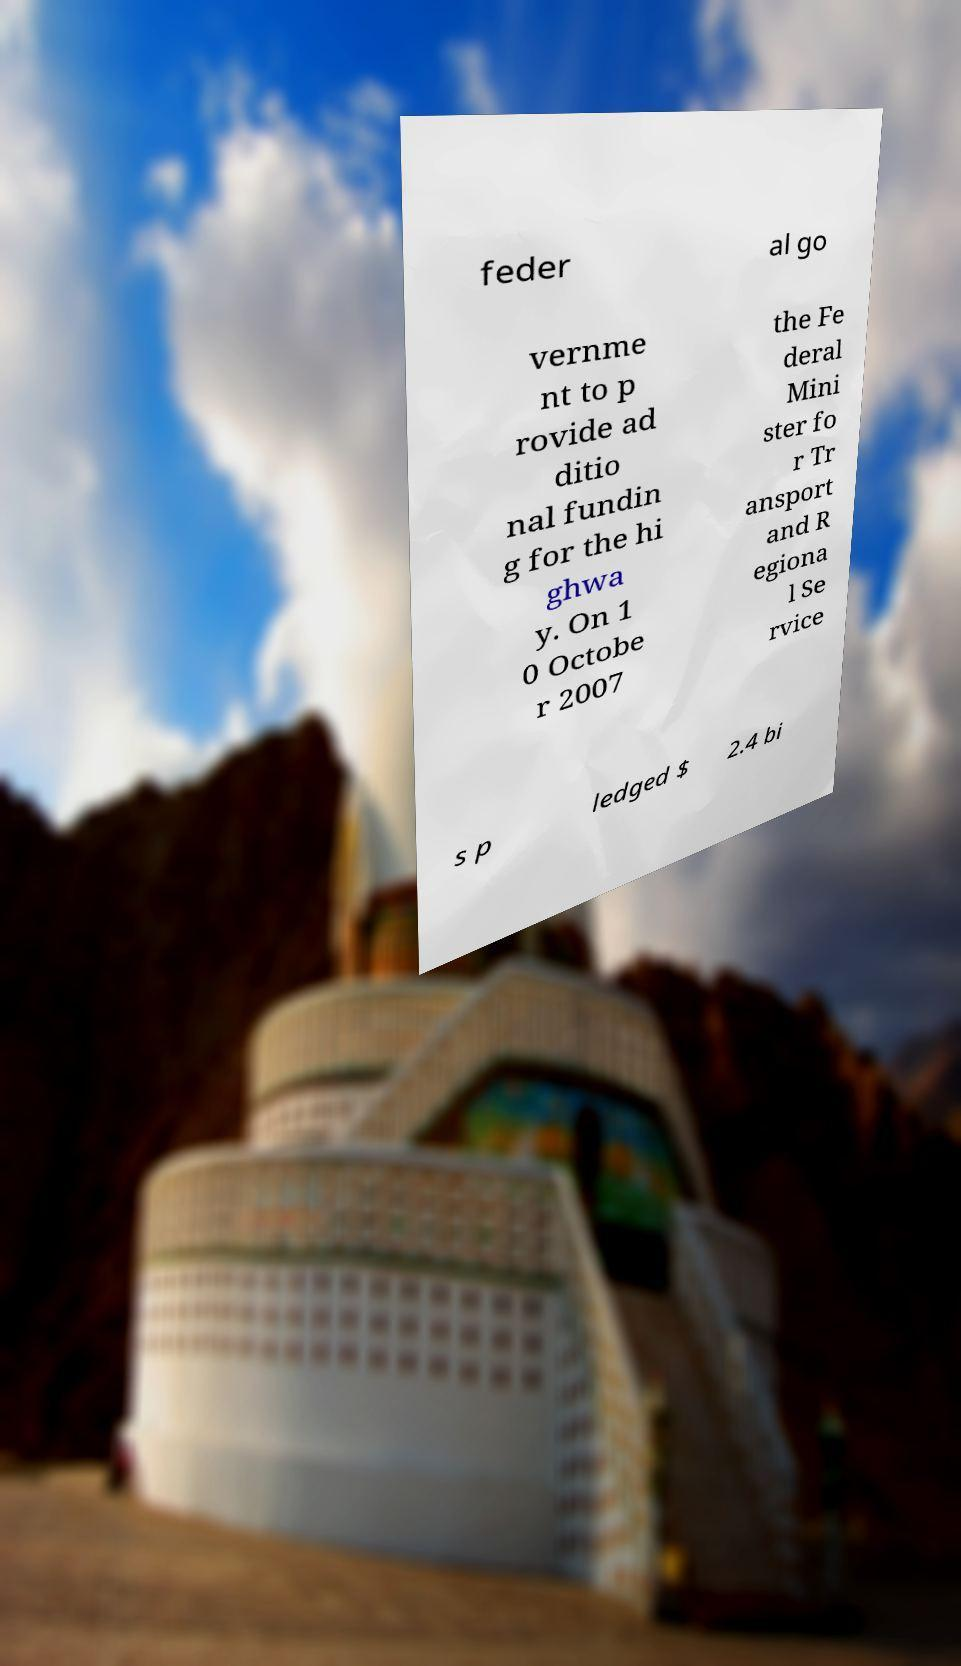I need the written content from this picture converted into text. Can you do that? feder al go vernme nt to p rovide ad ditio nal fundin g for the hi ghwa y. On 1 0 Octobe r 2007 the Fe deral Mini ster fo r Tr ansport and R egiona l Se rvice s p ledged $ 2.4 bi 